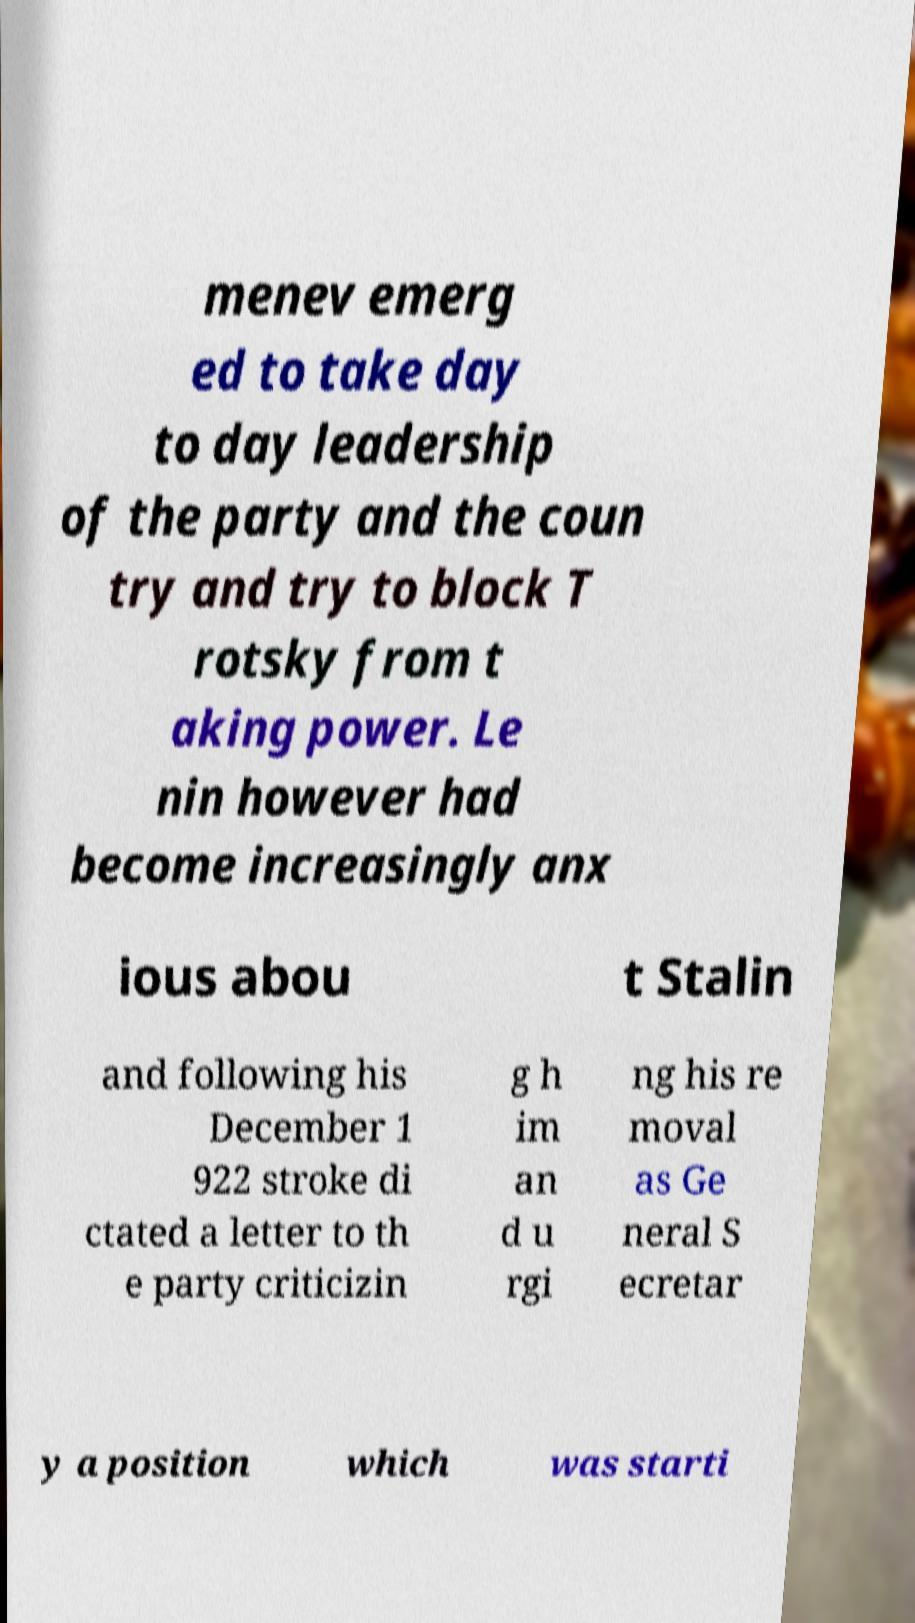Could you extract and type out the text from this image? menev emerg ed to take day to day leadership of the party and the coun try and try to block T rotsky from t aking power. Le nin however had become increasingly anx ious abou t Stalin and following his December 1 922 stroke di ctated a letter to th e party criticizin g h im an d u rgi ng his re moval as Ge neral S ecretar y a position which was starti 